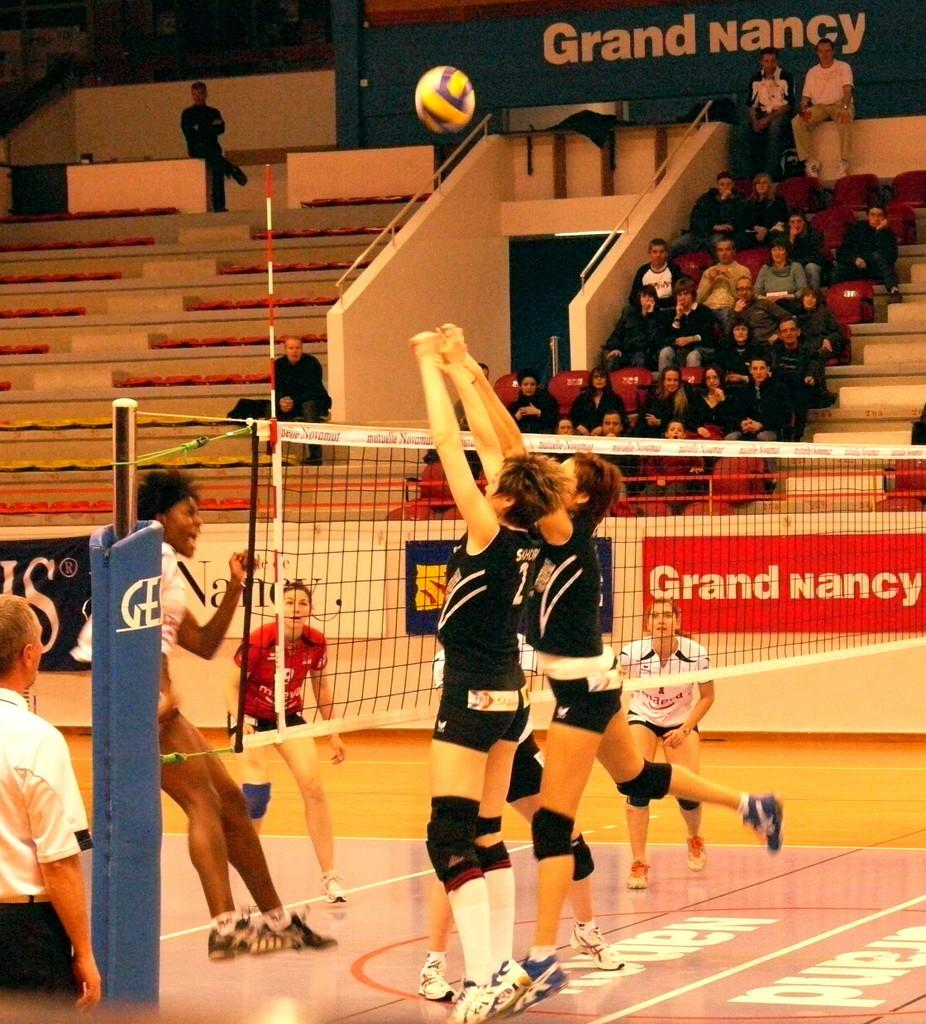Provide a one-sentence caption for the provided image. Women playing volleyball with a giant red sign that says Grand Nancy. 